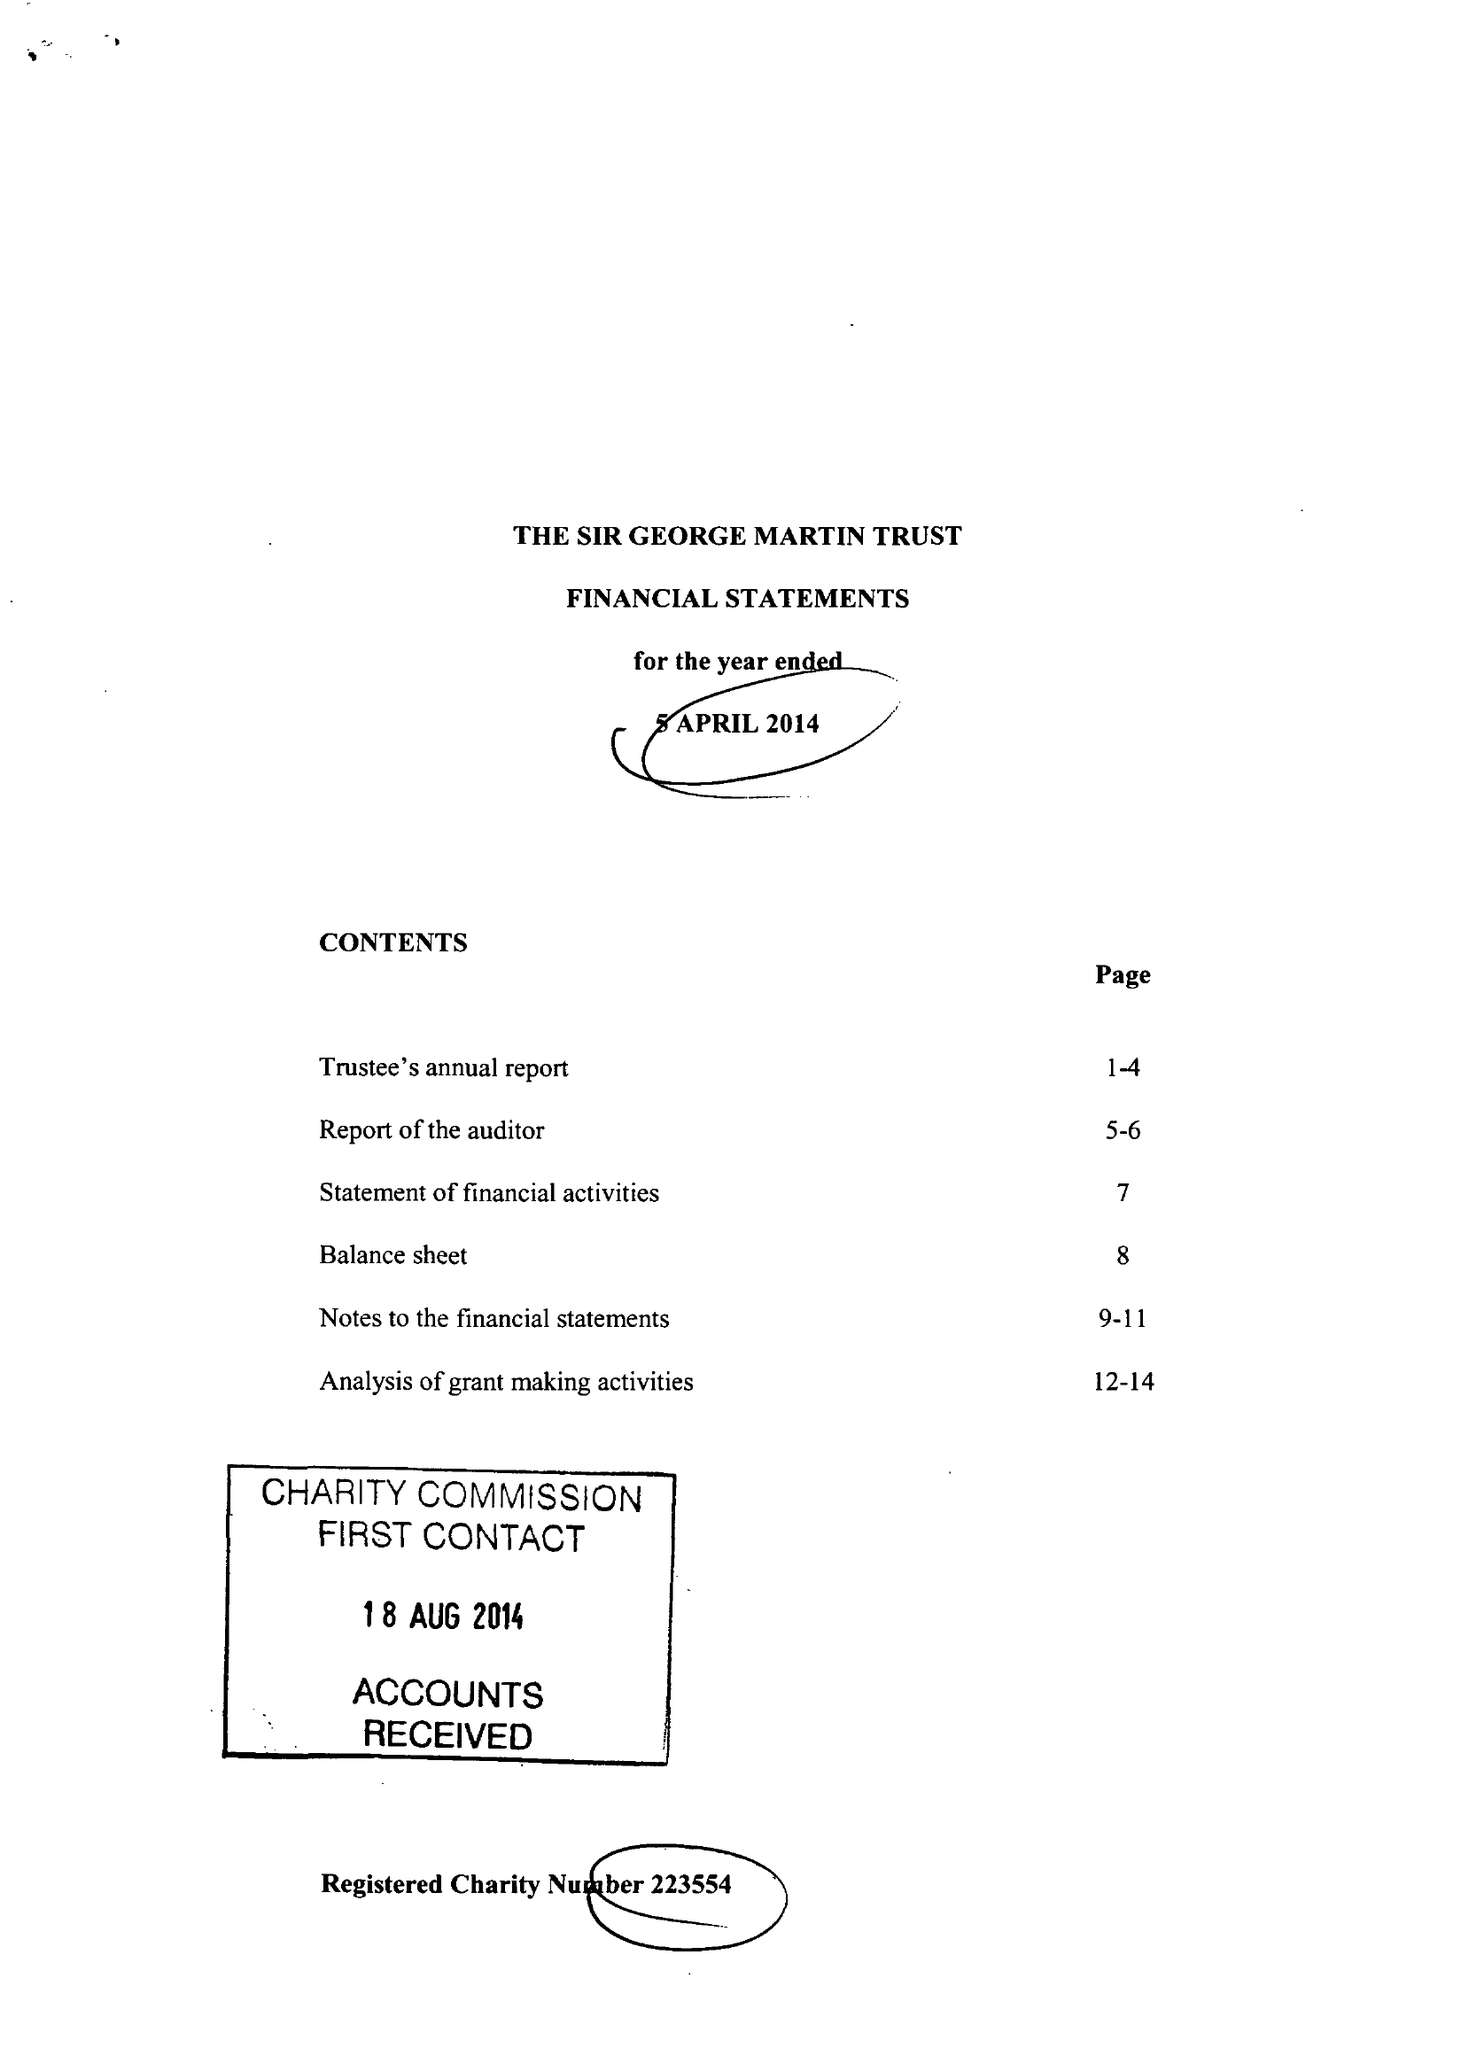What is the value for the address__post_town?
Answer the question using a single word or phrase. HARROGATE 